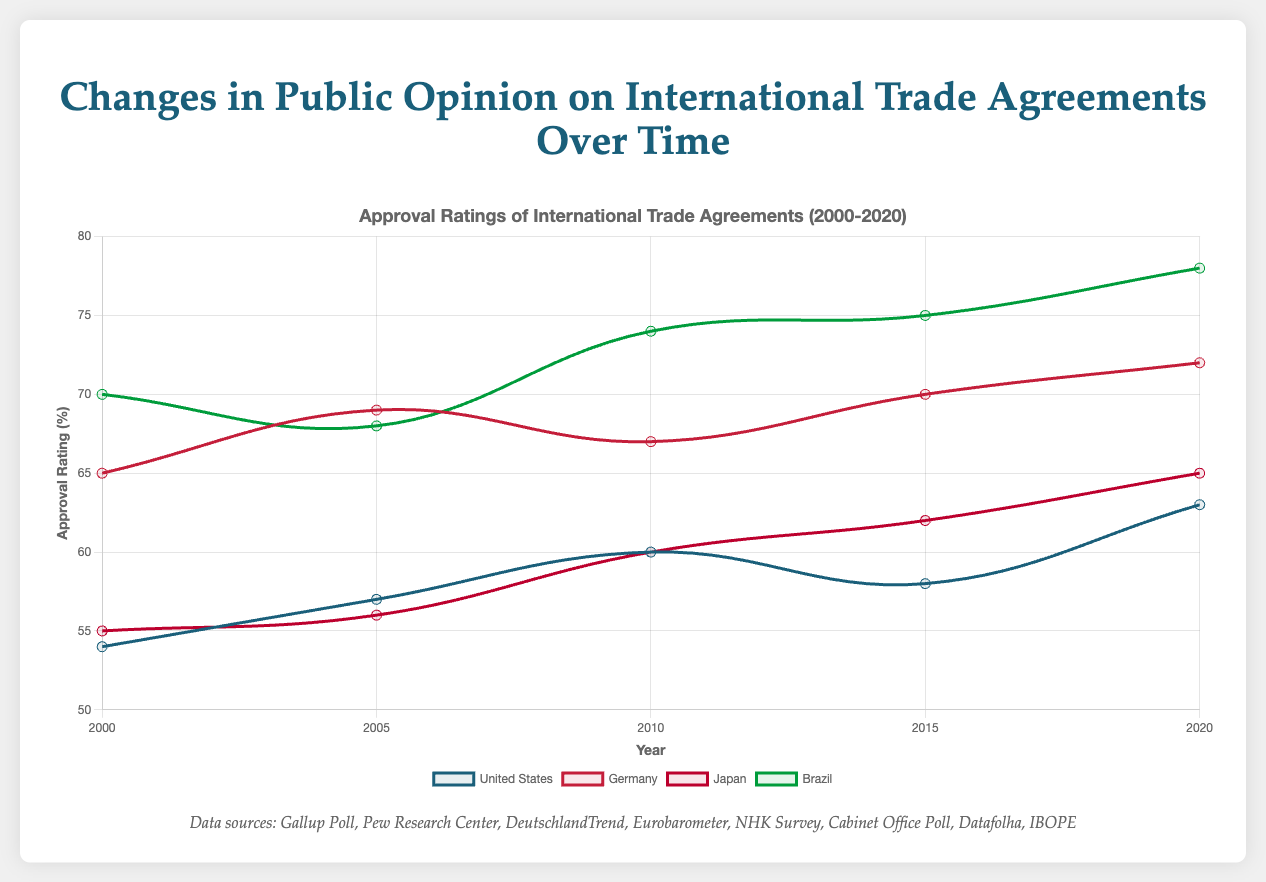Which country had the highest approval rating in 2000? By looking at the figure, the highest approval rating in 2000 is represented by the country with the highest point on the chart for that year. Brazil's approval rating in 2000 is 70%, which is the highest among the countries.
Answer: Brazil Has Japan's approval rating consistently increased over the years? Observing Japan's line on the chart, we see that the approval ratings rise from 2000 (55%), 2005 (56%), 2010 (60%), 2015 (62%), to 2020 (65%). This shows a consistent increase.
Answer: Yes In which year did Germany see a drop in approval rating? To find the year Germany saw a drop, we need to check the changes in approval ratings over the years. The approval rating dropped from 69% in 2005 to 67% in 2010.
Answer: 2010 What's the average approval rating of the United States from 2000 to 2020? Sum the approval ratings for the United States across all the given years (54 + 57 + 60 + 58 + 63) = 292, then divide by the number of data points (5): 292 / 5 = 58.4
Answer: 58.4 Which country showed the greatest increase in approval rating from 2000 to 2020? Calculate the increase for each country:
- United States: 63 - 54 = 9
- Germany: 72 - 65 = 7
- Japan: 65 - 55 = 10
- Brazil: 78 - 70 = 8
Japan showed the greatest increase with 10 points.
Answer: Japan Compare the approval ratings of the United States and Germany in 2015. Which one is higher? By visually comparing the data points for 2015, the approval rating is 58% for the United States and 70% for Germany. Germany's rating is higher.
Answer: Germany What is the average approval rating across all four countries in 2020? Sum the 2020 approval ratings for all countries (63 + 72 + 65 + 78) = 278, then divide by the number of countries (4): 278 / 4 = 69.5
Answer: 69.5 How many years did Brazil’s approval rating stay the same or increase? By examining the chart, Brazil's approval rating remained the same or increased in each interval: 
- 2000 to 2005: 70 to 68 (decrease)
- 2005 to 2010: 68 to 74
- 2010 to 2015: 74 to 75
- 2015 to 2020: 75 to 78
So, it stayed the same or increased in 3 out of 4 intervals.
Answer: 3 Which country had an approval rating closest to Japan's in 2020? By looking at the 2020 data points, Japan's approval rating is 65%. The closest value is for the United States with an approval rating of 63%.
Answer: United States 